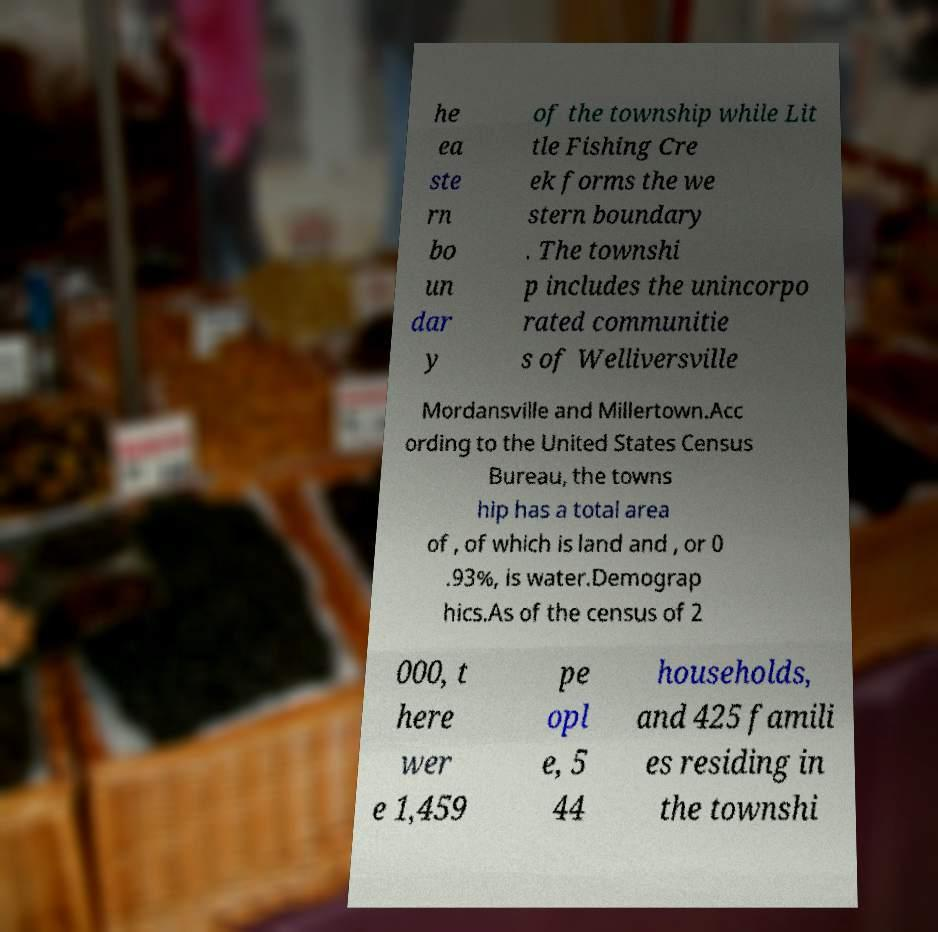Can you read and provide the text displayed in the image?This photo seems to have some interesting text. Can you extract and type it out for me? he ea ste rn bo un dar y of the township while Lit tle Fishing Cre ek forms the we stern boundary . The townshi p includes the unincorpo rated communitie s of Welliversville Mordansville and Millertown.Acc ording to the United States Census Bureau, the towns hip has a total area of , of which is land and , or 0 .93%, is water.Demograp hics.As of the census of 2 000, t here wer e 1,459 pe opl e, 5 44 households, and 425 famili es residing in the townshi 